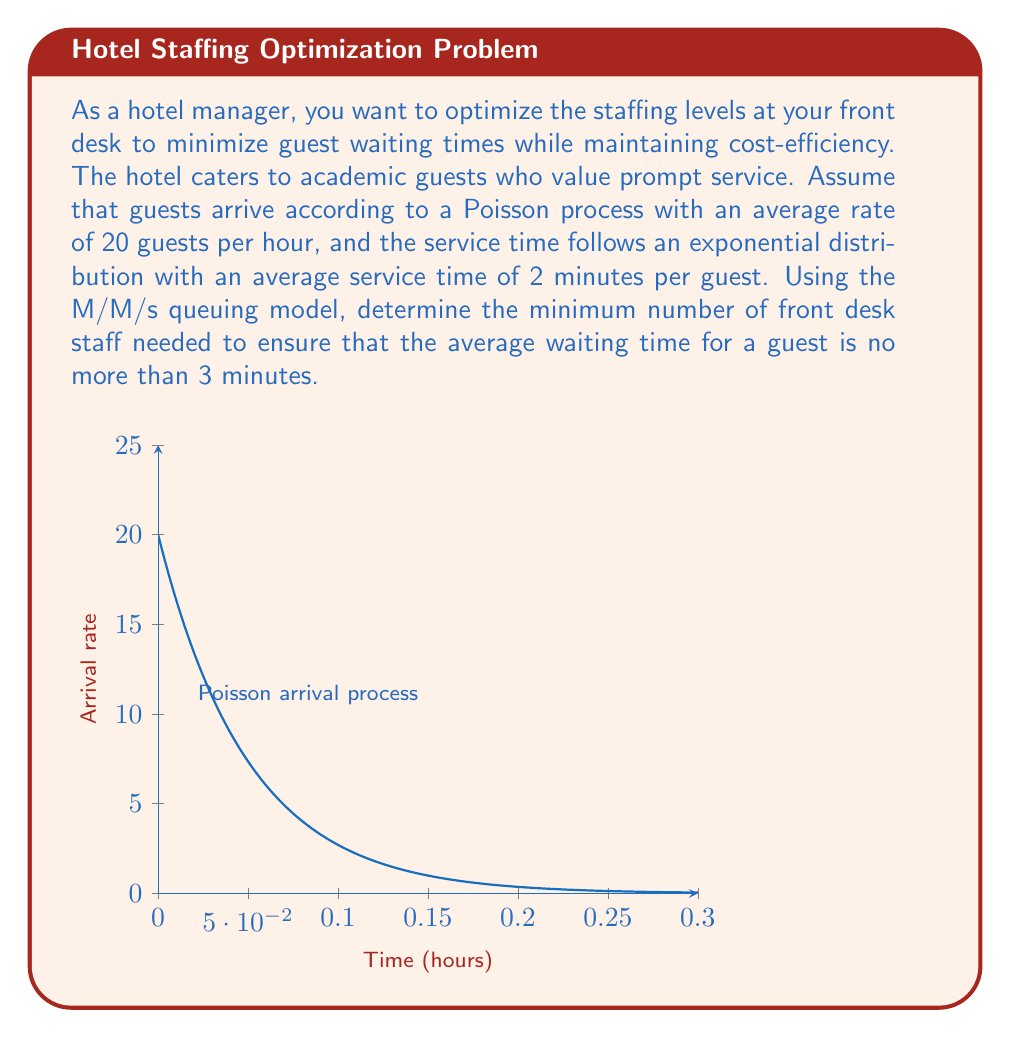Give your solution to this math problem. To solve this problem, we'll use the M/M/s queuing model, where M/M denotes Markovian arrival and service processes, and s is the number of servers (staff members).

Step 1: Define the parameters
- Arrival rate: $\lambda = 20$ guests/hour
- Service rate: $\mu = 60/2 = 30$ guests/hour (converting 2 minutes to hourly rate)
- Maximum average waiting time: $W_q = 3/60 = 0.05$ hours

Step 2: Calculate the utilization factor $\rho = \frac{\lambda}{s\mu}$
We need to find the minimum s such that the average waiting time is no more than 3 minutes.

Step 3: Use the M/M/s queuing formula for average waiting time:

$$W_q = \frac{P_0(\lambda/\mu)^s\rho}{s!(1-\rho)^2}\cdot\frac{1}{s\mu}$$

Where $P_0$ is the probability of an empty system:

$$P_0 = \left[\sum_{n=0}^{s-1}\frac{(\lambda/\mu)^n}{n!} + \frac{(\lambda/\mu)^s}{s!(1-\rho)}\right]^{-1}$$

Step 4: Iterate through values of s until we find the smallest s that satisfies $W_q \leq 0.05$

For s = 1: $\rho = 20/30 = 0.667 > 1$ (unstable system)
For s = 2: $\rho = 20/(2*30) = 0.333$, $W_q \approx 0.0833$ hours > 0.05
For s = 3: $\rho = 20/(3*30) = 0.222$, $W_q \approx 0.0185$ hours < 0.05

Step 5: Verify the result
With 3 staff members:
- Utilization: $\rho = 0.222$
- $P_0 \approx 0.259$
- $W_q \approx 0.0185$ hours = 1.11 minutes < 3 minutes

Therefore, the minimum number of front desk staff needed is 3.
Answer: 3 staff members 